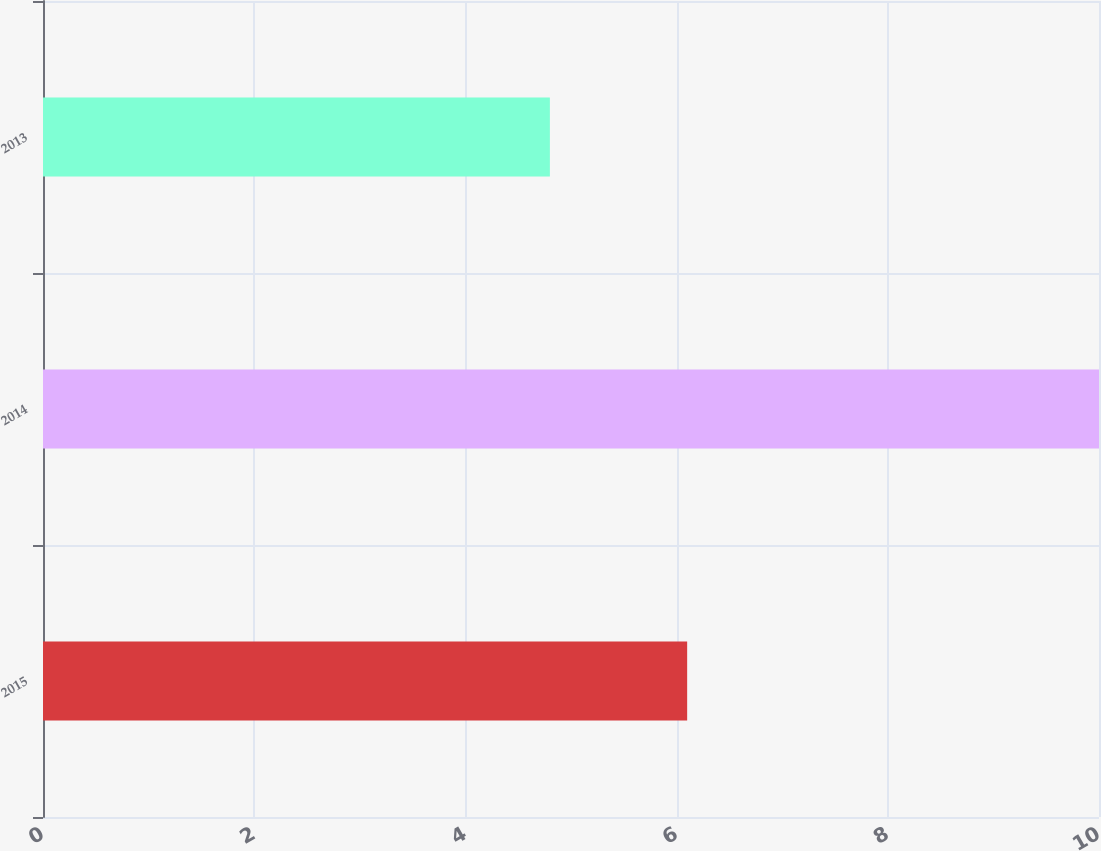Convert chart. <chart><loc_0><loc_0><loc_500><loc_500><bar_chart><fcel>2015<fcel>2014<fcel>2013<nl><fcel>6.1<fcel>10<fcel>4.8<nl></chart> 